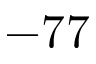Convert formula to latex. <formula><loc_0><loc_0><loc_500><loc_500>- 7 7</formula> 